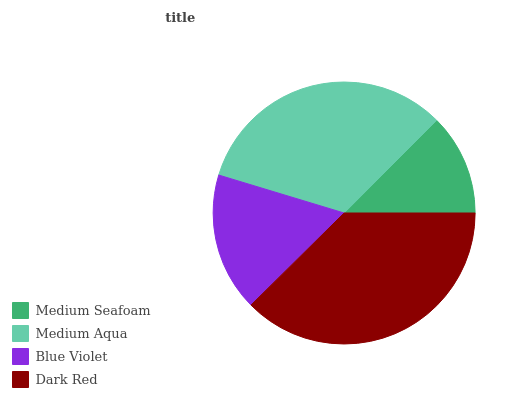Is Medium Seafoam the minimum?
Answer yes or no. Yes. Is Dark Red the maximum?
Answer yes or no. Yes. Is Medium Aqua the minimum?
Answer yes or no. No. Is Medium Aqua the maximum?
Answer yes or no. No. Is Medium Aqua greater than Medium Seafoam?
Answer yes or no. Yes. Is Medium Seafoam less than Medium Aqua?
Answer yes or no. Yes. Is Medium Seafoam greater than Medium Aqua?
Answer yes or no. No. Is Medium Aqua less than Medium Seafoam?
Answer yes or no. No. Is Medium Aqua the high median?
Answer yes or no. Yes. Is Blue Violet the low median?
Answer yes or no. Yes. Is Medium Seafoam the high median?
Answer yes or no. No. Is Medium Aqua the low median?
Answer yes or no. No. 